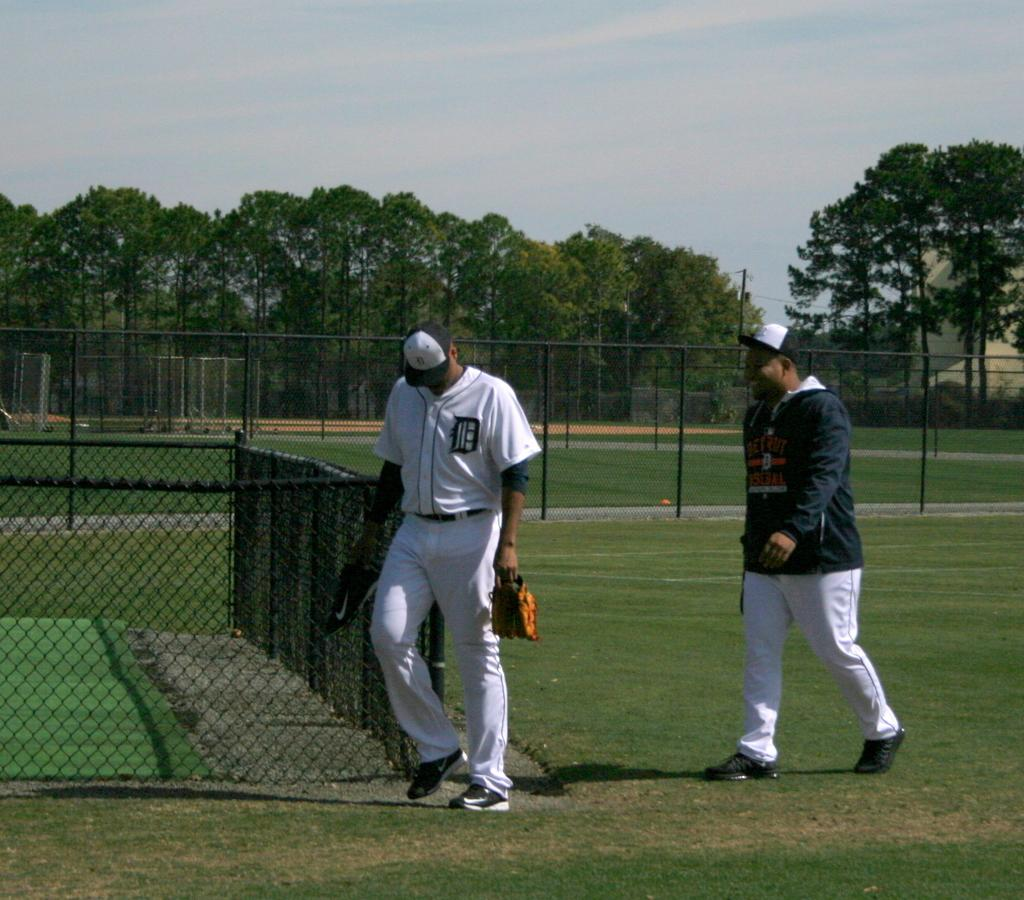How many people are in the image? There are two men in the center of the image. What is the setting of the image? The men are on a grassland. What can be seen around the men in the image? There is a net boundary in the image. What is visible in the background of the image? There are trees in the background of the image. Can you tell me how many cherries are on the ground in the image? There are no cherries present in the image. What type of question is the snake asking in the image? There is no snake or question present in the image. 